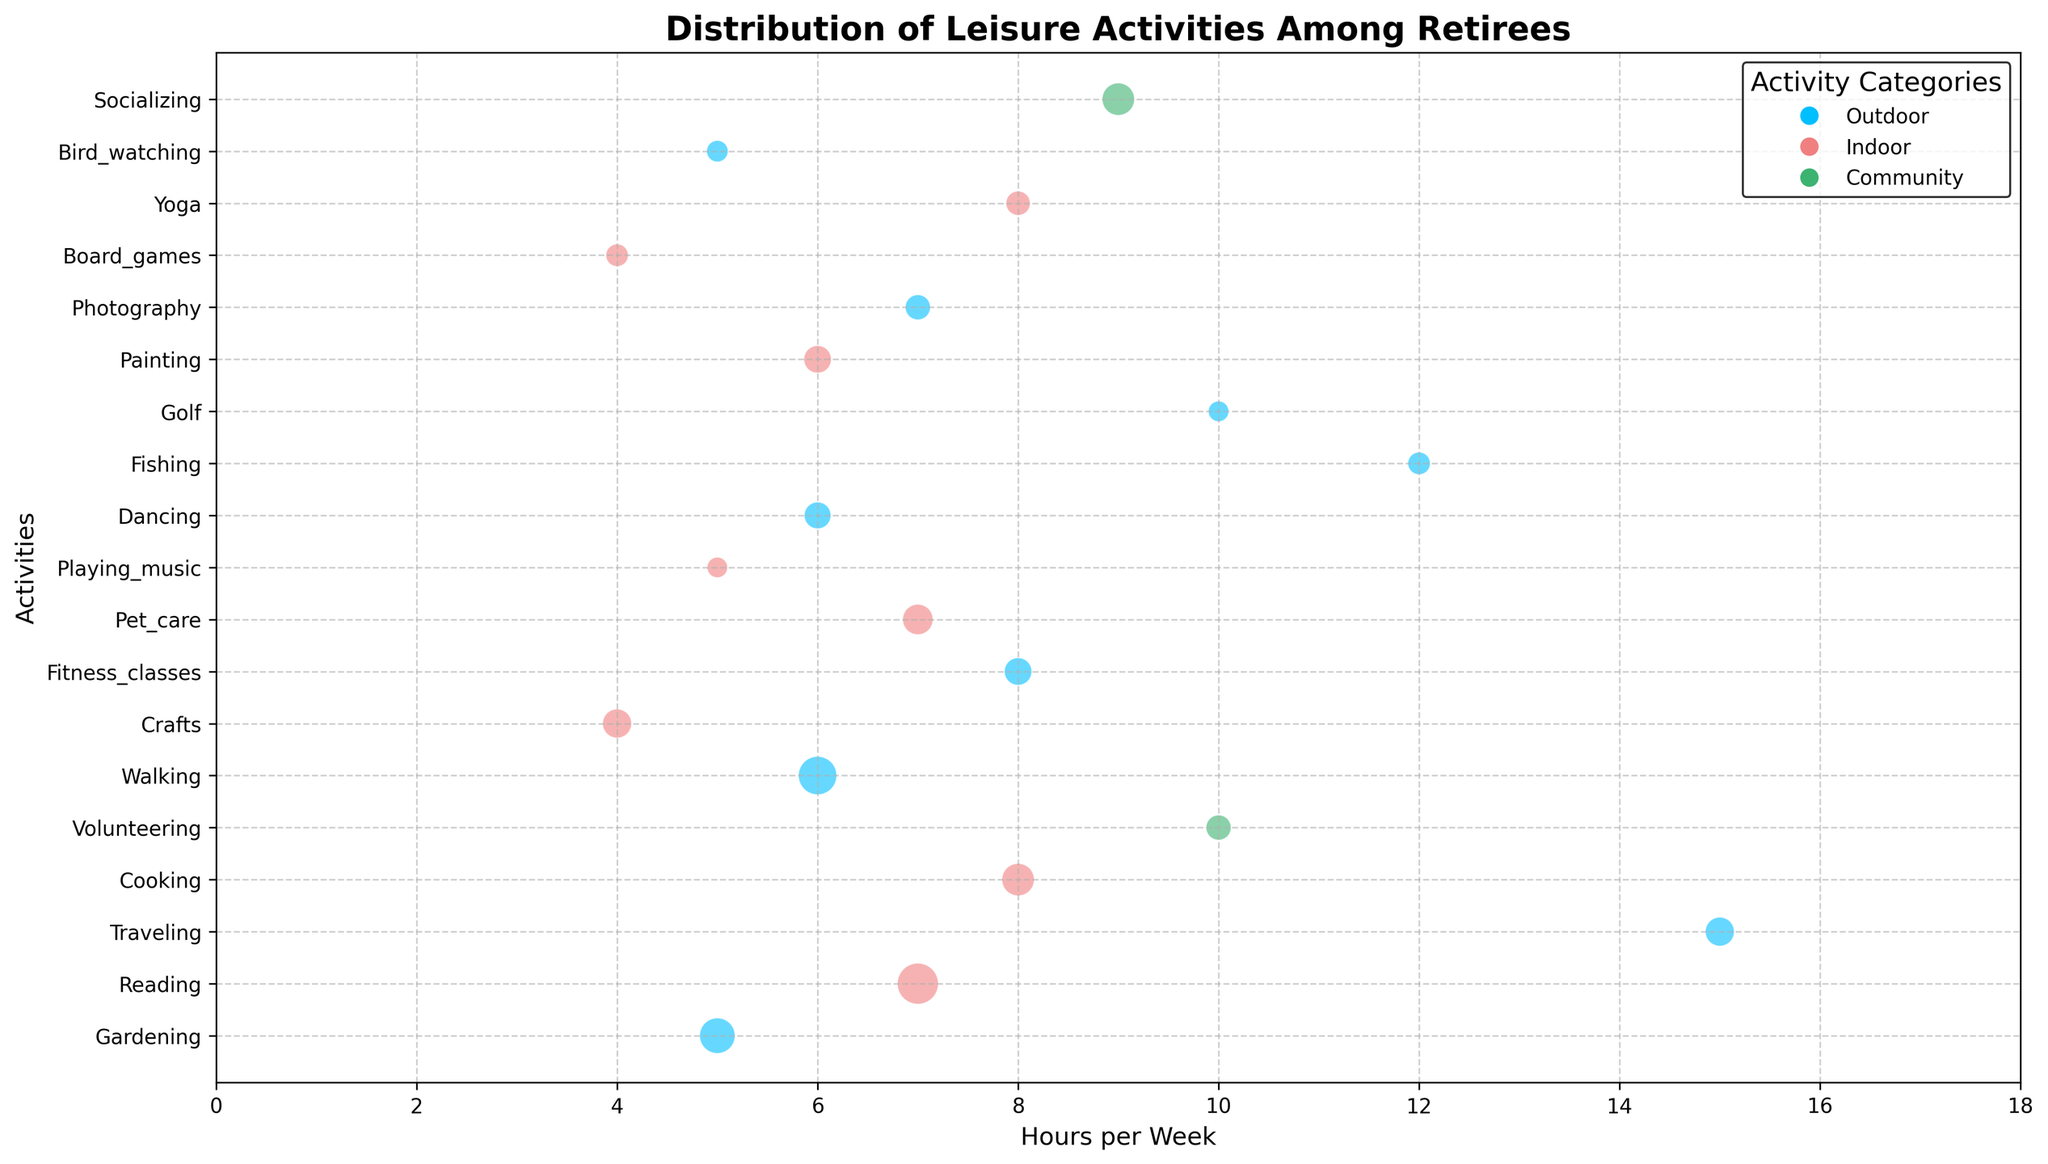What is the activity with the most hours per week? By observing the x-axis, we look for the activity placed furthest to the right, which indicates higher hours per week. Traveling is the activity furthest to the right at 15 hours per week.
Answer: Traveling Which indoor activity has the highest number of retirees? The indoor activities are shown in light coral. Among them, Reading has the largest bubble, indicating the highest number of retirees.
Answer: Reading How does the number of retirees for Fishing compare to Yoga? Comparing the sizes of the bubbles for both activities, Fishing has a larger bubble than Yoga, indicating a greater number of retirees (12 for Fishing vs. 14 for Yoga).
Answer: Fishing has fewer retirees than Yoga What's the total number of retirees participating in outdoor activities? Sum the number of retirees for all outdoor activities: Gardening (30) + Traveling (20) + Walking (35) + Fitness classes (18) + Dancing (17) + Fishing (12) + Golf (10) + Bird watching (11) + Photography (15) = 168.
Answer: 168 Which community activity is more popular in terms of hours per week? The community activities (green bubbles) are Volunteering and Socializing. Socializing is placed further on the x-axis at 9 hours per week, compared to Volunteering's 10 hours per week.
Answer: Socializing What are the total hours per week spent on activities with fewer than 20 retirees? Identify the activities with fewer than 20 retirees and sum their hours per week: Playing_music (5) + Dancing (6) + Fishing (12) + Golf (10) + Photography (7) + Board Games (4) + Yoga (8) + Bird Watching (5) = 57.
Answer: 57 Which outdoor activity has the least number of hours per week? Among the blue bubbles, the activity closest to the left on the x-axis is Gardening and Bird watching, both at 5 hours per week.
Answer: Gardening or Bird watching (both at 5 hours per week) How does the number of retirees for Gardening compare to Socializing? Gardening has 30 retirees, while Socializing has 25 retirees. Comparing the bubble sizes visually, Gardening has a larger bubble.
Answer: Gardening has more retirees What is the average number of hours per week for all indoor activities? Sum the hours of all indoor activities and divide by the number of indoor activities: (Reading 7 + Cooking 8 + Crafts 4 + Pet care 7 + Playing music 5 + Painting 6 + Board_games 4 + Yoga 8) / 8 = 49 / 8 = 6.125.
Answer: 6.125 